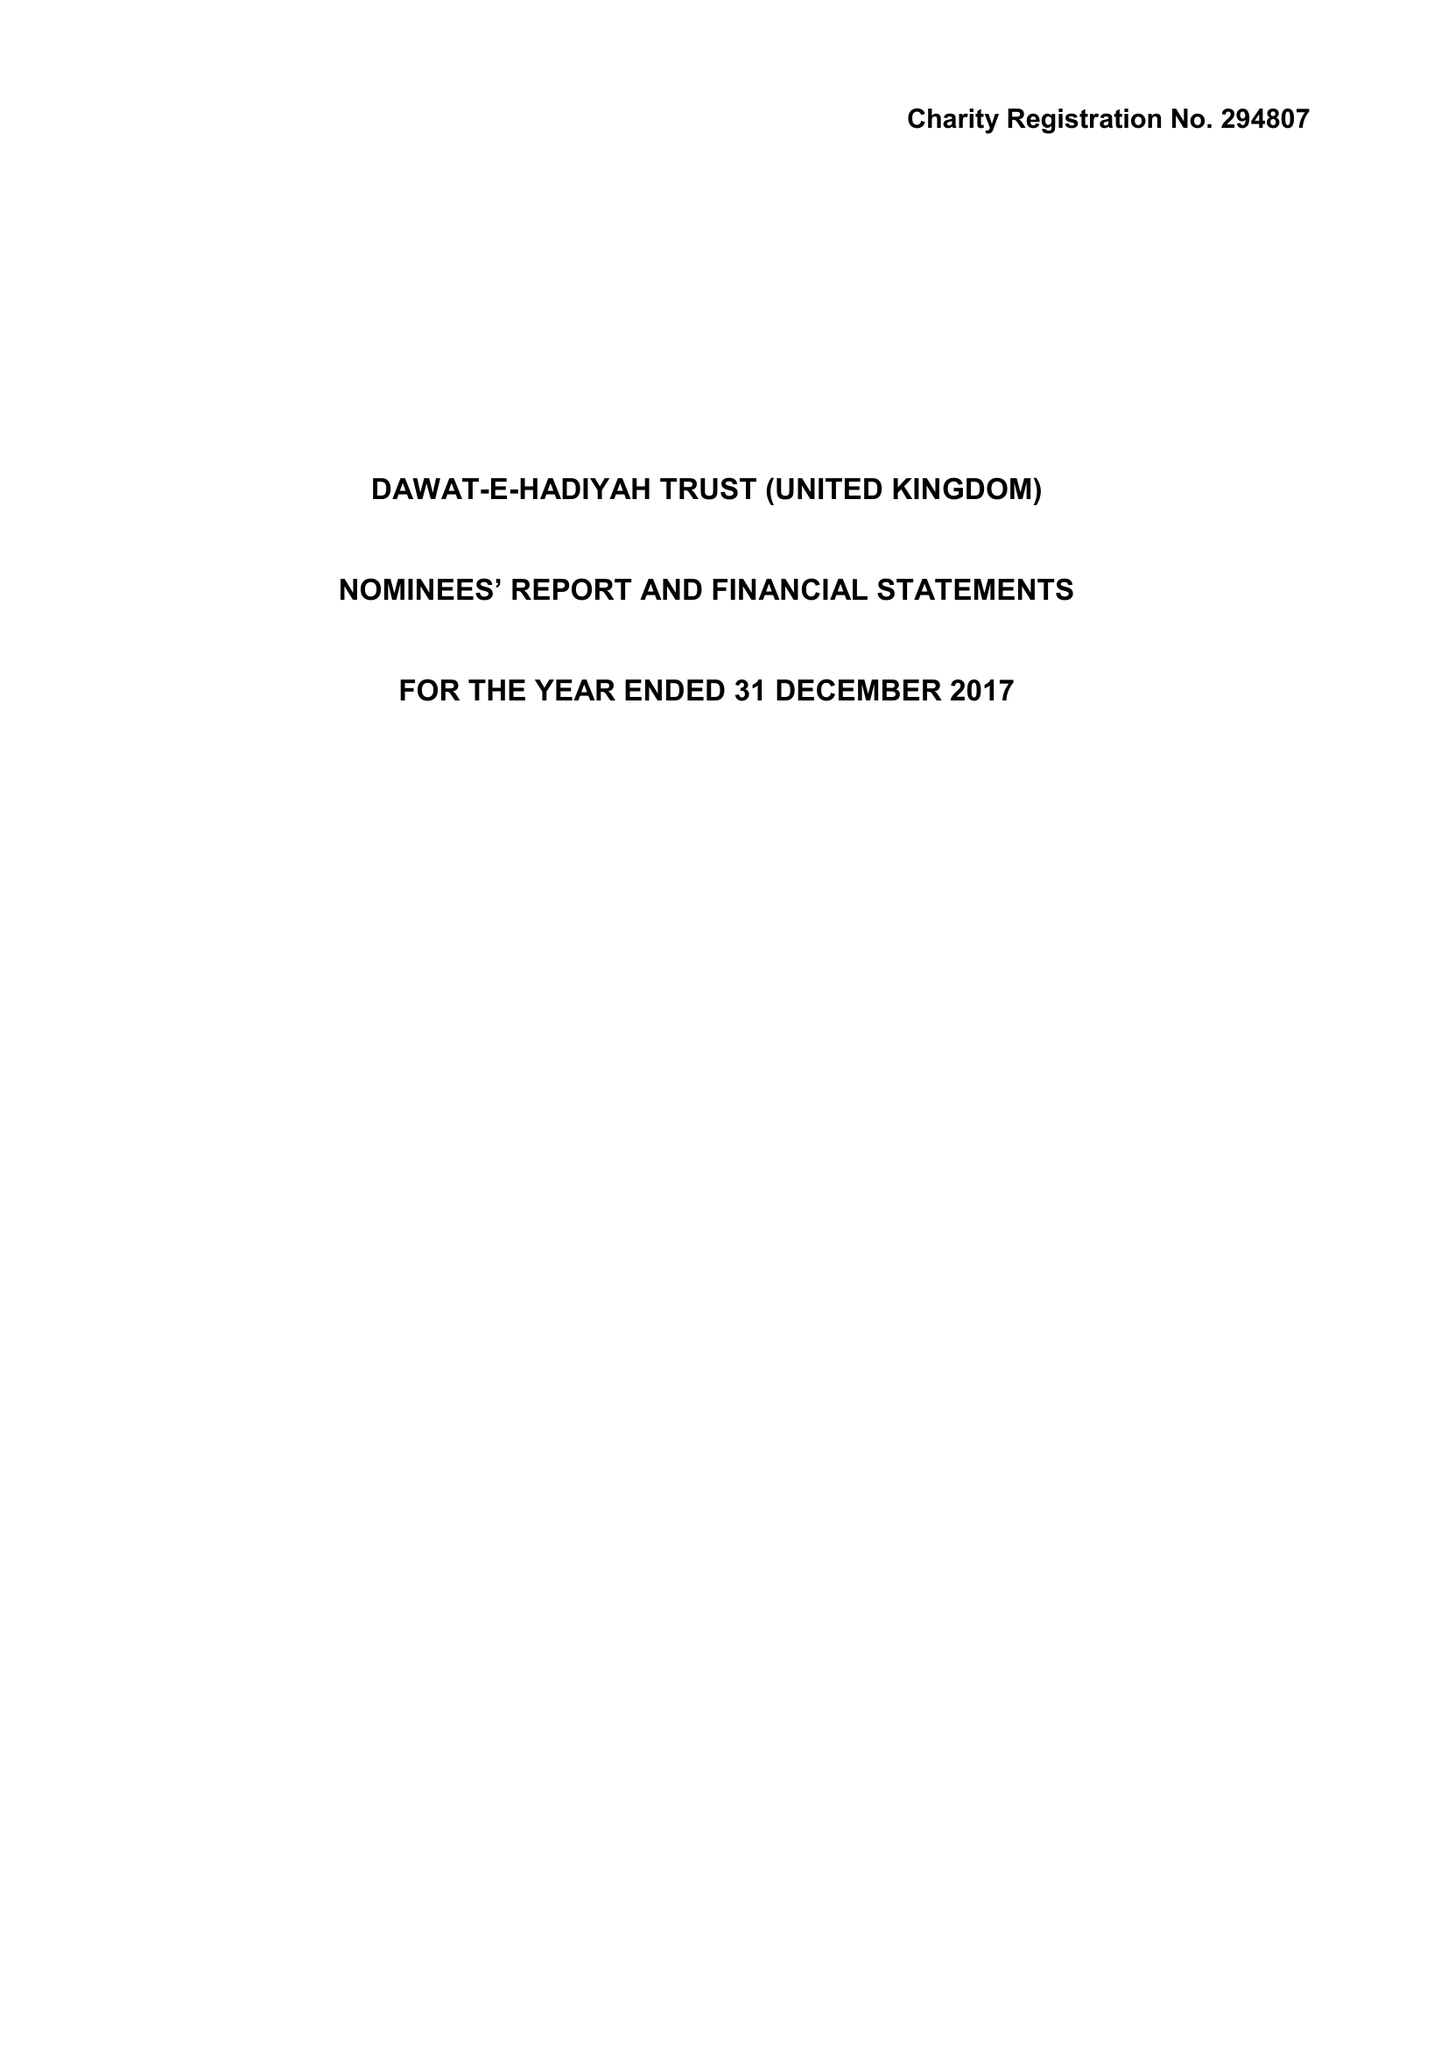What is the value for the spending_annually_in_british_pounds?
Answer the question using a single word or phrase. 12329515.00 